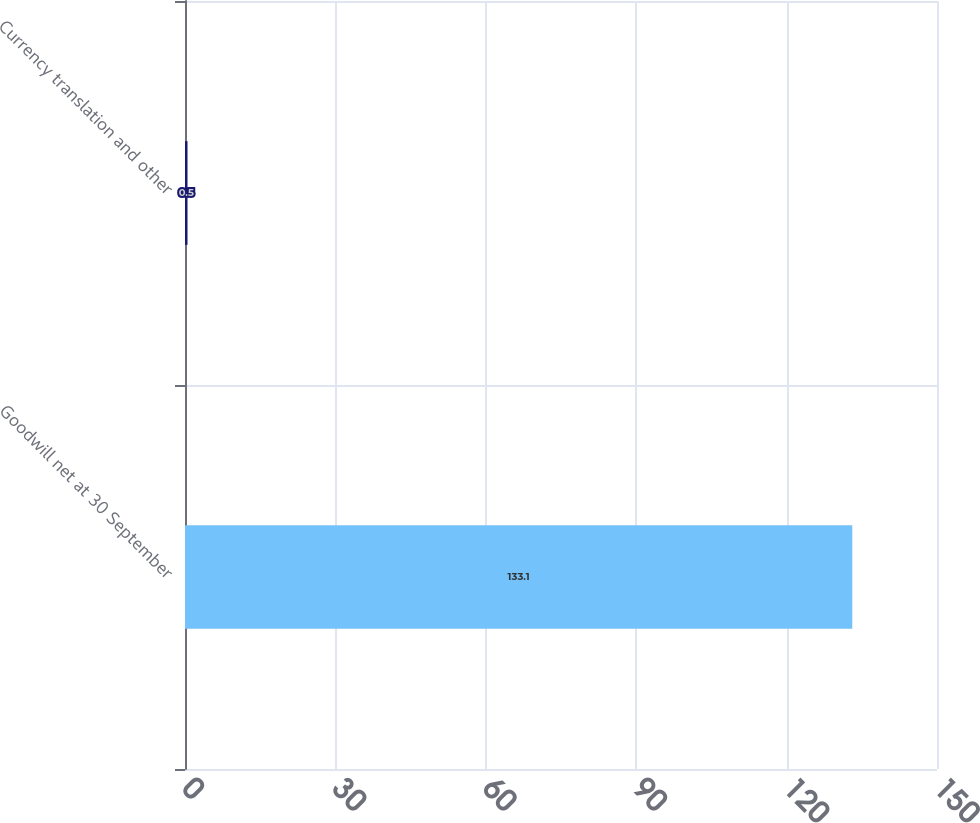Convert chart to OTSL. <chart><loc_0><loc_0><loc_500><loc_500><bar_chart><fcel>Goodwill net at 30 September<fcel>Currency translation and other<nl><fcel>133.1<fcel>0.5<nl></chart> 